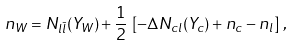<formula> <loc_0><loc_0><loc_500><loc_500>n _ { W } = N _ { l \bar { l } } ( Y _ { W } ) + \frac { 1 } { 2 } \, \left [ - \Delta N _ { c l } ( Y _ { c } ) + n _ { c } - n _ { l } \right ] \, ,</formula> 